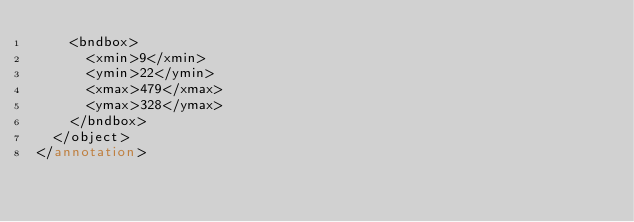<code> <loc_0><loc_0><loc_500><loc_500><_XML_>    <bndbox>
      <xmin>9</xmin>
      <ymin>22</ymin>
      <xmax>479</xmax>
      <ymax>328</ymax>
    </bndbox>
  </object>
</annotation>
</code> 